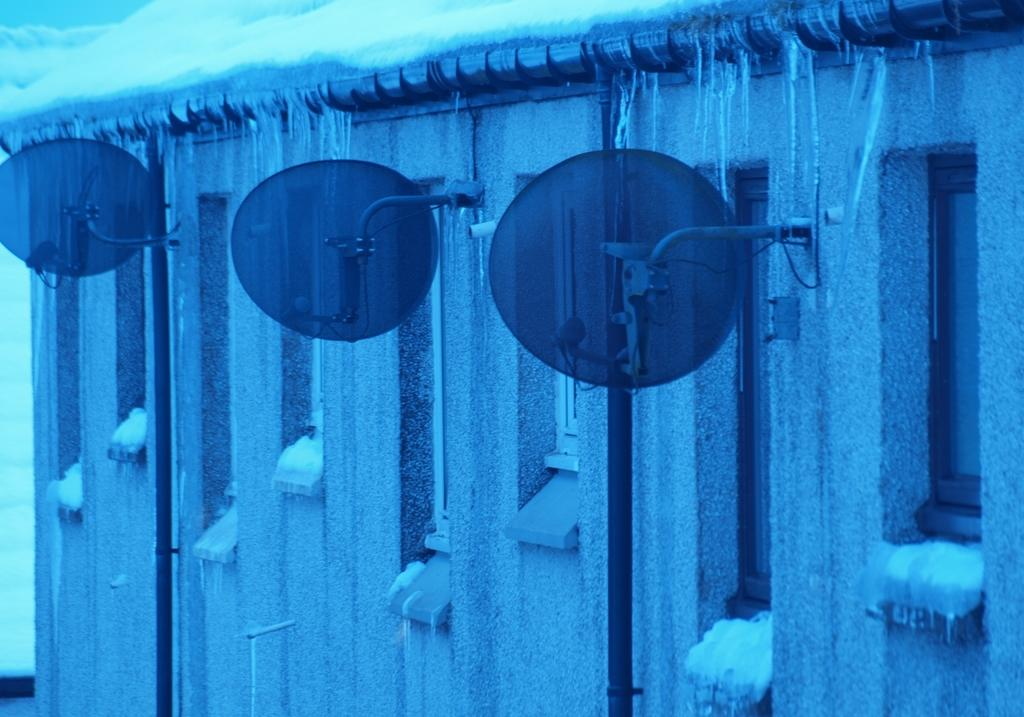What structures can be seen in the image? There are poles and boards in the image. What architectural feature is present in the image? There is a wall in the image. What can be seen through the wall? There are windows in the image. What is the weather like in the image? There is snow visible in the image, indicating a cold or wintry environment. What type of rice is being cooked in the image? There is no rice present in the image. Can you see any animals in the image? There are no animals visible in the image. 